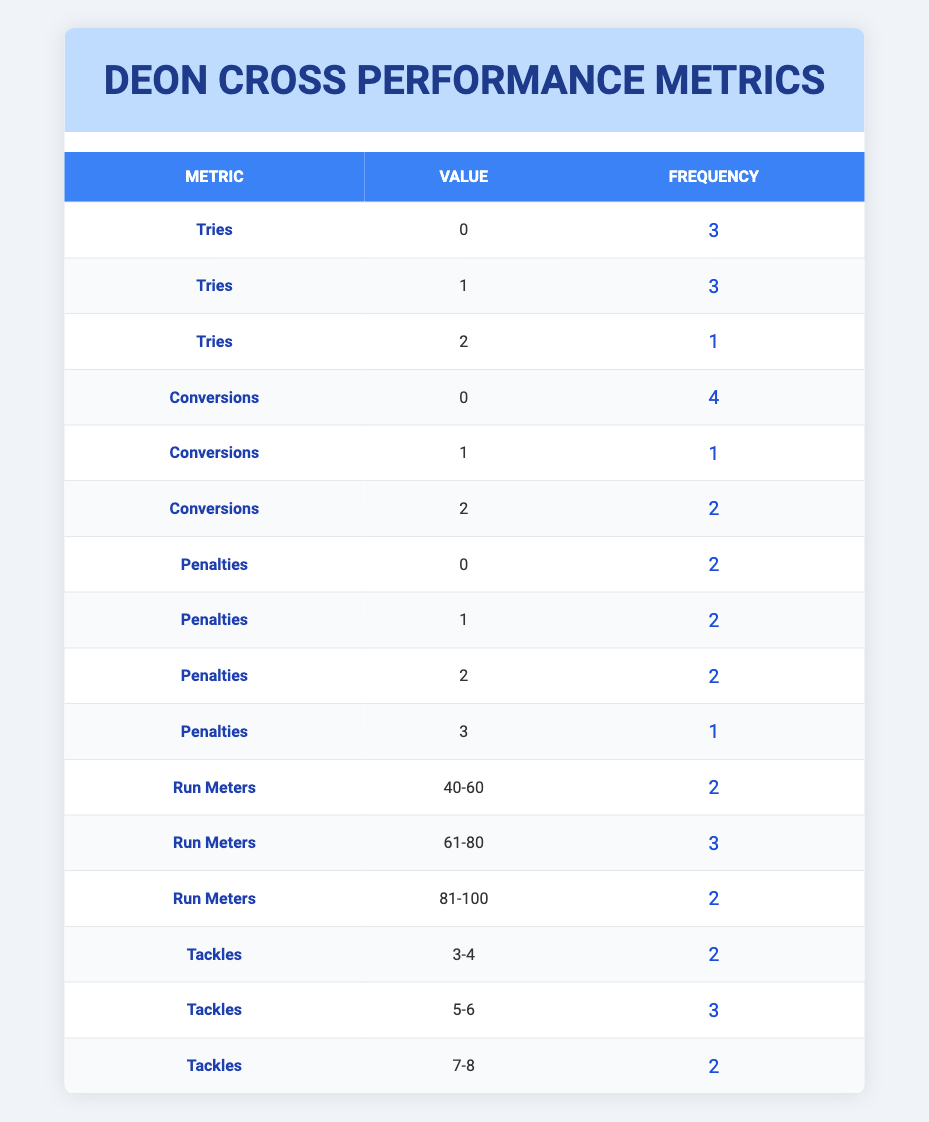What is the frequency of games where Deon scored 0 tries? According to the table, there are 3 entries where the value of tries is 0, corresponding to matches against the Crusaders, Brumbies, and Stormers.
Answer: 3 How many times did Deon score 2 tries? The table shows that the value of tries being 2 appears only once, in the match against the Highlanders.
Answer: 1 What is the maximum number of run meters recorded by Deon in a match? By examining the "Run Meters" section, the highest value is 100, noted in the match against the Highlanders.
Answer: 100 Did Deon have more games with 1 penalty or 2 penalties? The table indicates he had 2 games where he scored 1 penalty and 2 games where he scored 2 penalties. Therefore, he had an equal frequency of games with both.
Answer: No What is the average number of penalties scored by Deon across all matches? The penalties scored are 2, 1, 0, 1, 3, 2, and 0. When added together, they total 9 penalties, which are then divided by the 7 matches to get the average, 9/7 ≈ 1.29.
Answer: 1.29 How many times did Deon make 6 or more tackles? By reviewing the "Tackles" section, the values 6 and 8 occur in the matches against the Highlanders (6 tackles) and the Brumbies (7 tackles), respectively. Additionally, he made 5 tackles against the Waratahs. Thus, he made 6 or more tackles in 3 matches.
Answer: 3 What percentage of matches did Deon score at least 1 conversion? Deon had conversions in 3 out of 7 matches for which the metric is provided. To find the percentage, (3/7) * 100 = approximately 42.86%.
Answer: 42.86% Was the number of games where Deon made 4 or more tackles equal to the number of games where he made 2 or fewer tackles? The table shows that Deon made 4 or more tackles in 5 matches and 2 or fewer tackles in 2 matches. Hence, they are not equal.
Answer: No What is the total number of conversions scored by Deon in all matches? By adding the conversions from each match, which are 0, 2, 1, 1, 0, 2, and 0, the total comes to 6.
Answer: 6 